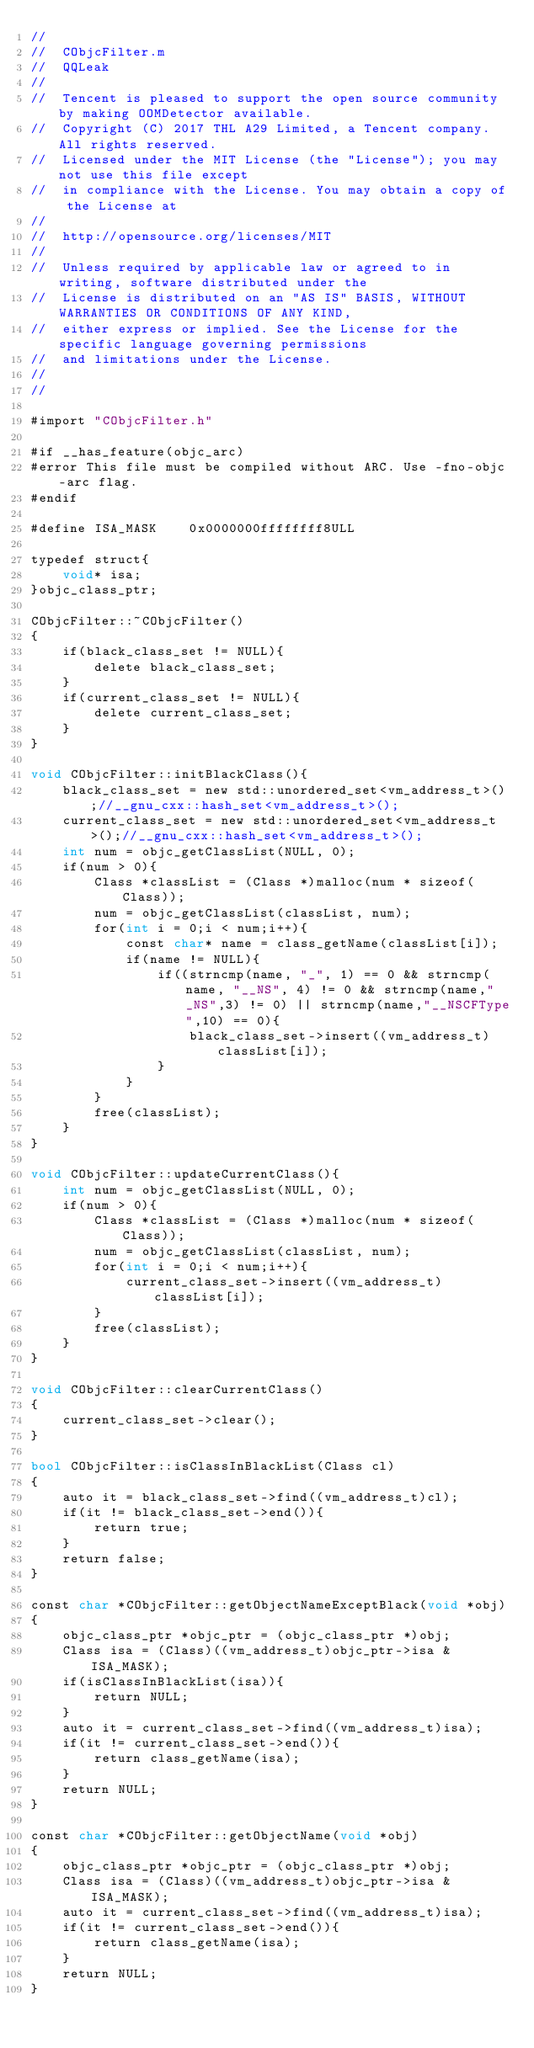<code> <loc_0><loc_0><loc_500><loc_500><_ObjectiveC_>//
//  CObjcFilter.m
//  QQLeak
//
//  Tencent is pleased to support the open source community by making OOMDetector available.
//  Copyright (C) 2017 THL A29 Limited, a Tencent company. All rights reserved.
//  Licensed under the MIT License (the "License"); you may not use this file except
//  in compliance with the License. You may obtain a copy of the License at
//
//  http://opensource.org/licenses/MIT
//
//  Unless required by applicable law or agreed to in writing, software distributed under the
//  License is distributed on an "AS IS" BASIS, WITHOUT WARRANTIES OR CONDITIONS OF ANY KIND,
//  either express or implied. See the License for the specific language governing permissions
//  and limitations under the License.
//
//

#import "CObjcFilter.h"

#if __has_feature(objc_arc)
#error This file must be compiled without ARC. Use -fno-objc-arc flag.
#endif

#define ISA_MASK    0x0000000ffffffff8ULL

typedef struct{
    void* isa;
}objc_class_ptr;

CObjcFilter::~CObjcFilter()
{
    if(black_class_set != NULL){
        delete black_class_set;
    }
    if(current_class_set != NULL){
        delete current_class_set;
    }
}

void CObjcFilter::initBlackClass(){
    black_class_set = new std::unordered_set<vm_address_t>();//__gnu_cxx::hash_set<vm_address_t>();
    current_class_set = new std::unordered_set<vm_address_t>();//__gnu_cxx::hash_set<vm_address_t>();
    int num = objc_getClassList(NULL, 0);
    if(num > 0){
        Class *classList = (Class *)malloc(num * sizeof(Class));
        num = objc_getClassList(classList, num);
        for(int i = 0;i < num;i++){
            const char* name = class_getName(classList[i]);
            if(name != NULL){
                if((strncmp(name, "_", 1) == 0 && strncmp(name, "__NS", 4) != 0 && strncmp(name,"_NS",3) != 0) || strncmp(name,"__NSCFType",10) == 0){
                    black_class_set->insert((vm_address_t)classList[i]);
                }
            }
        }
        free(classList);
    }
}

void CObjcFilter::updateCurrentClass(){
    int num = objc_getClassList(NULL, 0);
    if(num > 0){
        Class *classList = (Class *)malloc(num * sizeof(Class));
        num = objc_getClassList(classList, num);
        for(int i = 0;i < num;i++){
            current_class_set->insert((vm_address_t)classList[i]);
        }
        free(classList);
    }
}

void CObjcFilter::clearCurrentClass()
{
    current_class_set->clear();
}

bool CObjcFilter::isClassInBlackList(Class cl)
{
    auto it = black_class_set->find((vm_address_t)cl);
    if(it != black_class_set->end()){
        return true;
    }
    return false;
}

const char *CObjcFilter::getObjectNameExceptBlack(void *obj)
{
    objc_class_ptr *objc_ptr = (objc_class_ptr *)obj;
    Class isa = (Class)((vm_address_t)objc_ptr->isa & ISA_MASK);
    if(isClassInBlackList(isa)){
        return NULL;
    }
    auto it = current_class_set->find((vm_address_t)isa);
    if(it != current_class_set->end()){
        return class_getName(isa);
    }
    return NULL;
}

const char *CObjcFilter::getObjectName(void *obj)
{
    objc_class_ptr *objc_ptr = (objc_class_ptr *)obj;
    Class isa = (Class)((vm_address_t)objc_ptr->isa & ISA_MASK);
    auto it = current_class_set->find((vm_address_t)isa);
    if(it != current_class_set->end()){
        return class_getName(isa);
    }
    return NULL;
}
</code> 